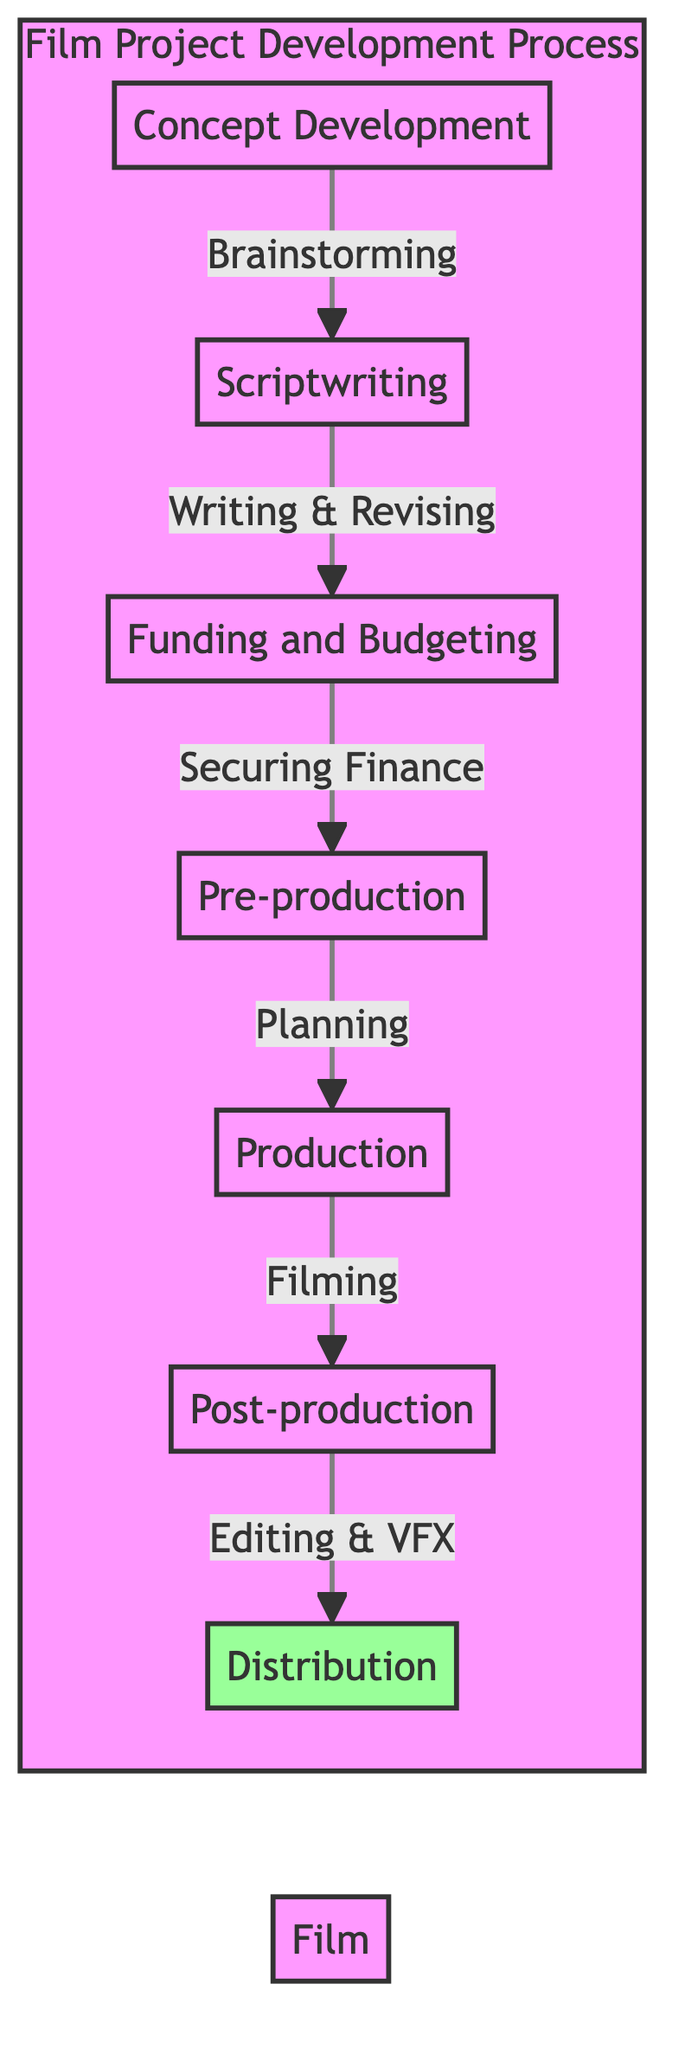What is the first stage in the film project development process? The first stage, as shown in the diagram, is "Concept Development," which represents the initial brainstorming of ideas and themes for the film.
Answer: Concept Development How many stages are depicted in the flow chart? The diagram illustrates a total of seven stages, which include Concept Development, Scriptwriting, Funding and Budgeting, Pre-production, Production, Post-production, and Distribution.
Answer: Seven What is the last step in the film project development process? The last step in the diagram is "Distribution," indicating the marketing and distributing of the film to audiences.
Answer: Distribution What stage comes after Funding and Budgeting? After the Funding and Budgeting stage, the next step is Pre-production, where planning all aspects of the film occurs, including casting and location scouting.
Answer: Pre-production Which stage includes writing and revising the screenplay? The stage that involves writing and revising the screenplay is "Scriptwriting." This step directly follows Concept Development.
Answer: Scriptwriting What type of activity does the Production stage involve? The Production stage involves the active filming of the actual scenes of the movie, marking a crucial phase in the development process.
Answer: Filming What is the relationship between Scriptwriting and Funding and Budgeting? The relationship is sequential. The Scriptwriting stage leads to Funding and Budgeting, as securing finances and determining the film's budget happens only after the screenplay is worked on.
Answer: Sequential Which stage is characterized by editing the film and adding visual effects? The stage characterized by editing the film and adding visual effects is "Post-production." This stage follows Production and is essential for finalizing the film before distribution.
Answer: Post-production What steps are involved after the Production stage? After the Production stage, the steps involved are Post-production, which includes editing and visual effects, followed by the Distribution stage to deliver the film to audiences.
Answer: Post-production, Distribution 